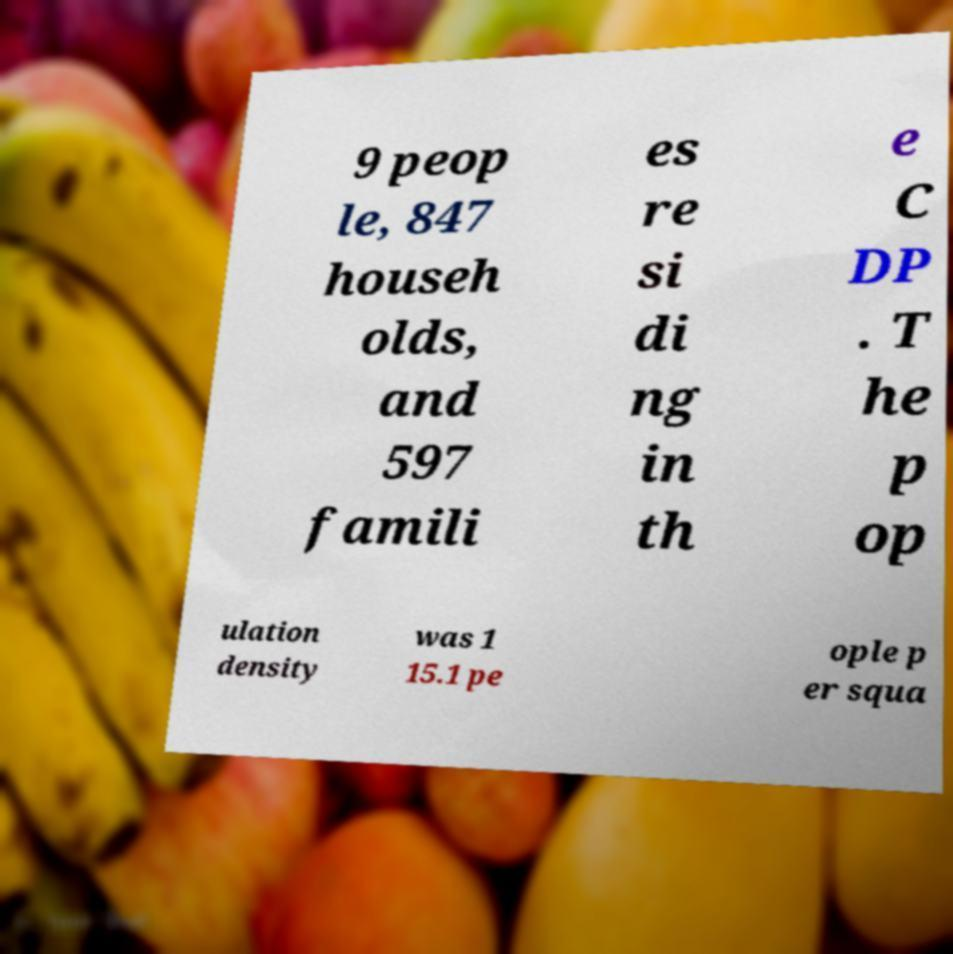Could you assist in decoding the text presented in this image and type it out clearly? 9 peop le, 847 househ olds, and 597 famili es re si di ng in th e C DP . T he p op ulation density was 1 15.1 pe ople p er squa 